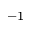Convert formula to latex. <formula><loc_0><loc_0><loc_500><loc_500>^ { - 1 }</formula> 